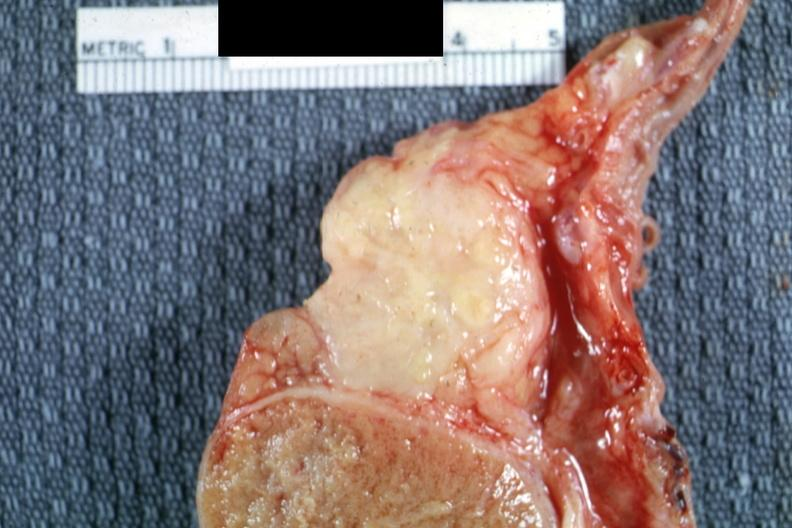what is present?
Answer the question using a single word or phrase. Epididymis 